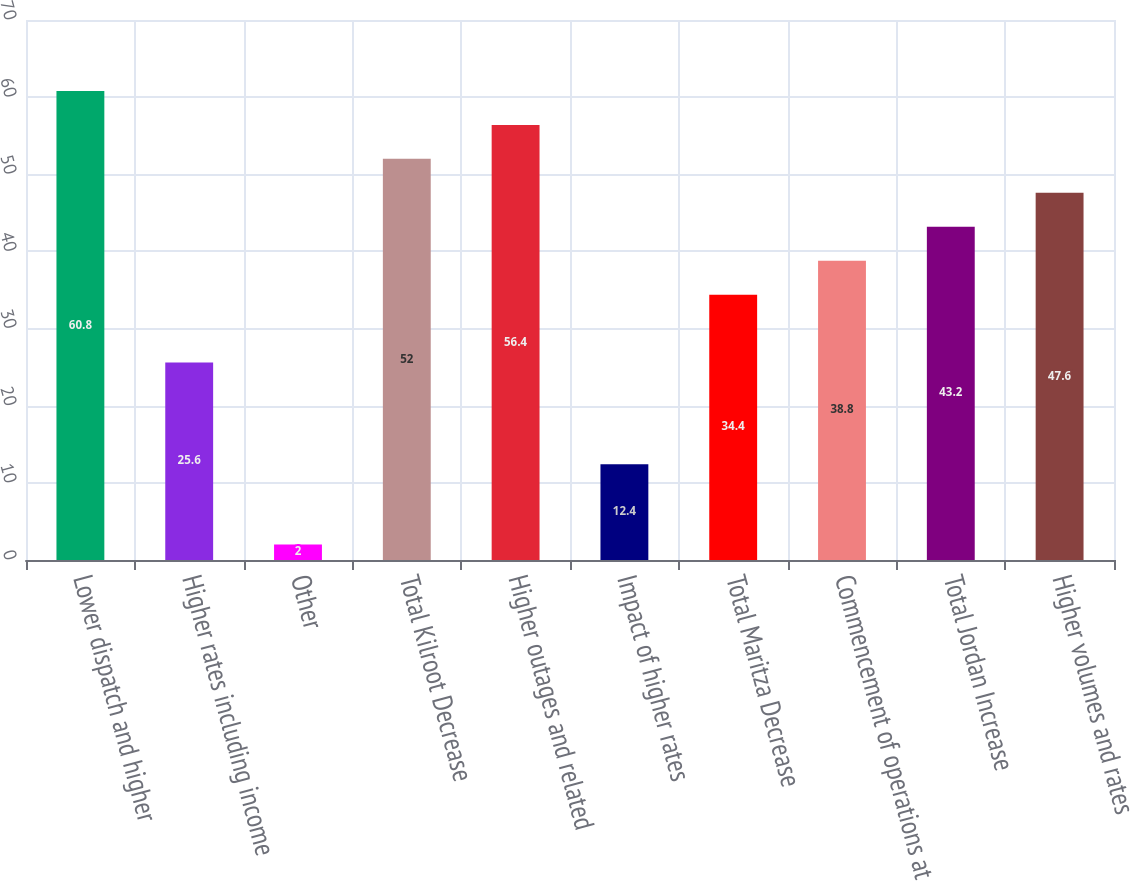Convert chart. <chart><loc_0><loc_0><loc_500><loc_500><bar_chart><fcel>Lower dispatch and higher<fcel>Higher rates including income<fcel>Other<fcel>Total Kilroot Decrease<fcel>Higher outages and related<fcel>Impact of higher rates<fcel>Total Maritza Decrease<fcel>Commencement of operations at<fcel>Total Jordan Increase<fcel>Higher volumes and rates<nl><fcel>60.8<fcel>25.6<fcel>2<fcel>52<fcel>56.4<fcel>12.4<fcel>34.4<fcel>38.8<fcel>43.2<fcel>47.6<nl></chart> 